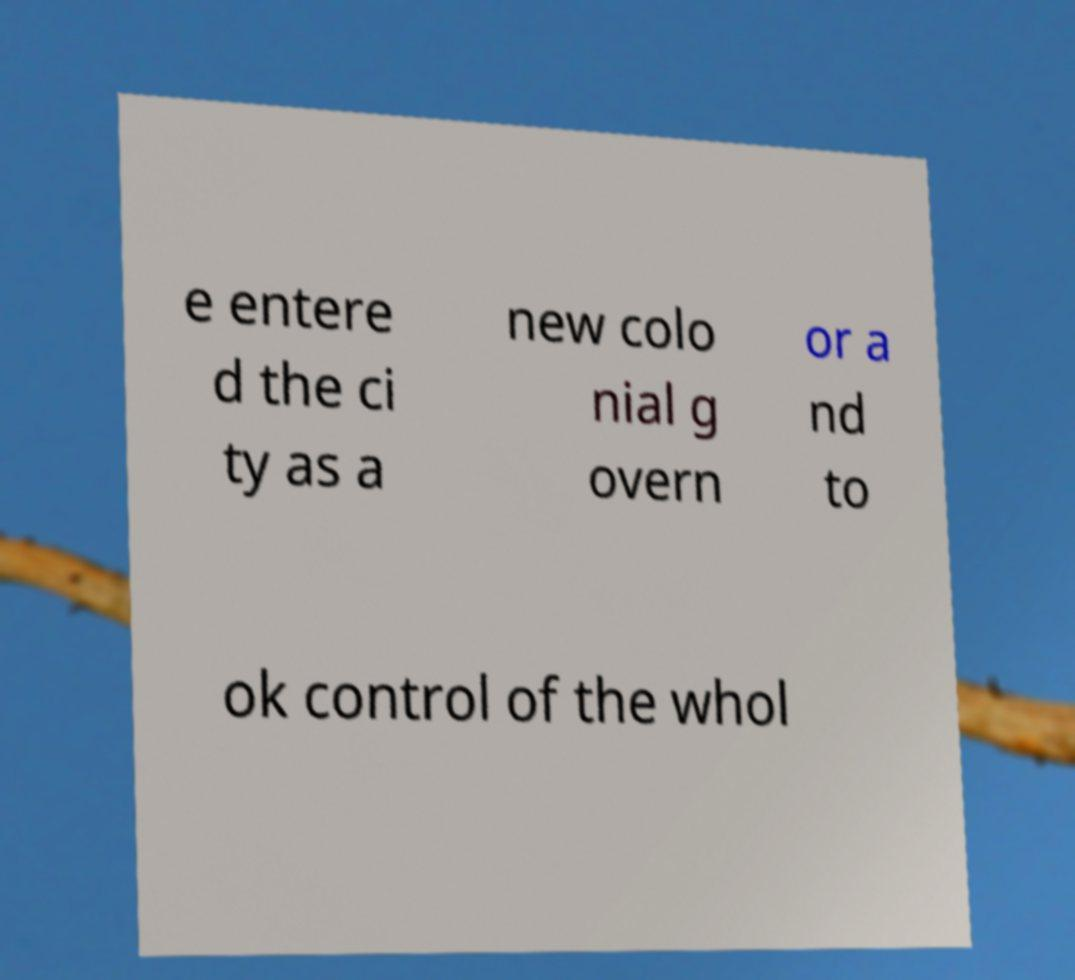Can you accurately transcribe the text from the provided image for me? e entere d the ci ty as a new colo nial g overn or a nd to ok control of the whol 